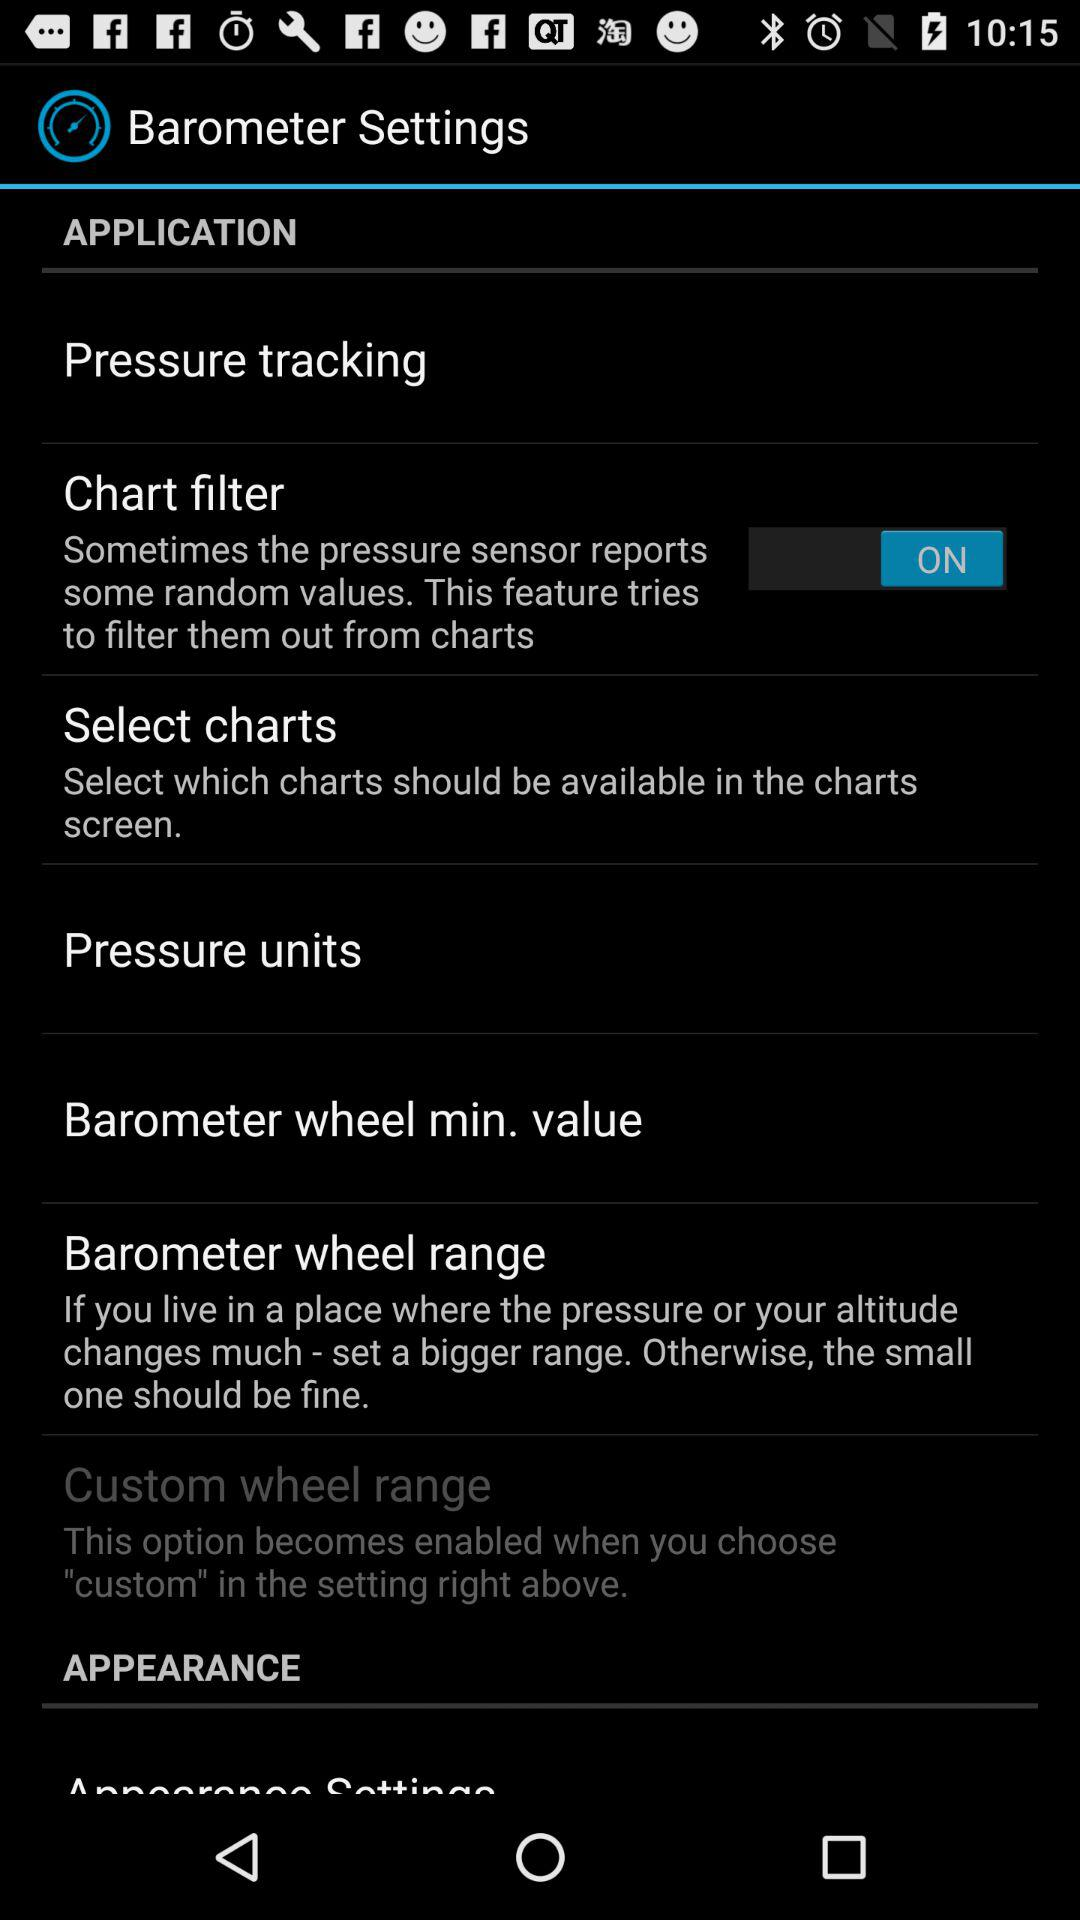Is "Pressure units" checked or unchecked?
When the provided information is insufficient, respond with <no answer>. <no answer> 